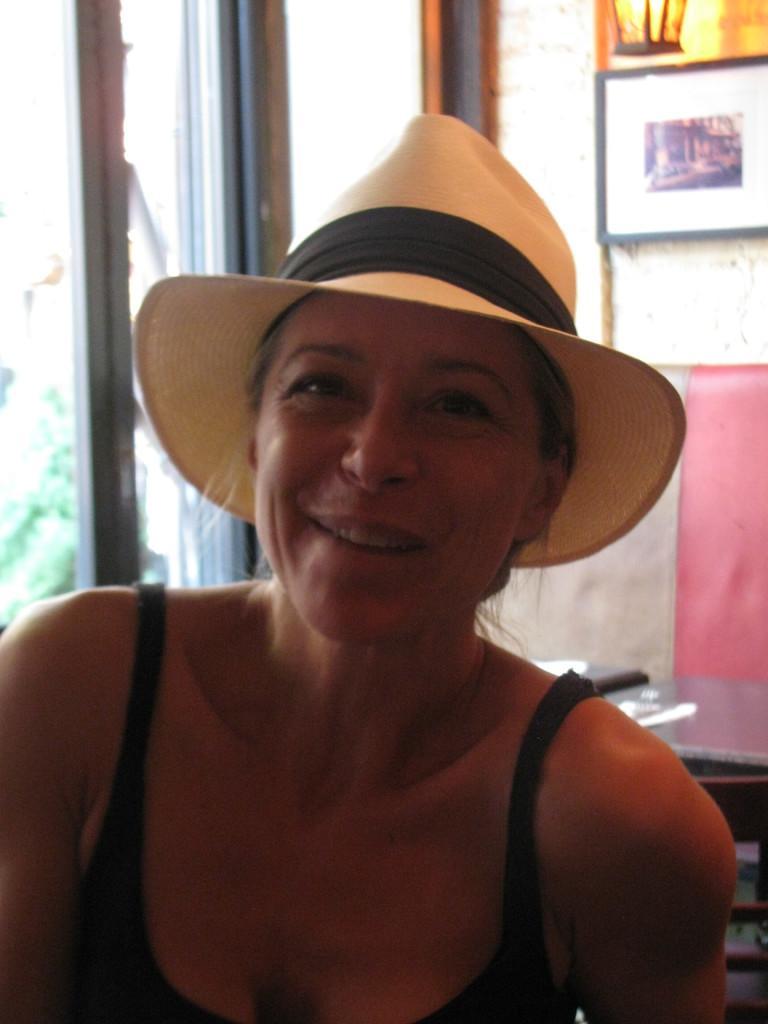How would you summarize this image in a sentence or two? In this image a lady is there in the foreground. She is wearing hat. In the background there is a table , there are photo frames on the wall. This is looking like a window. 